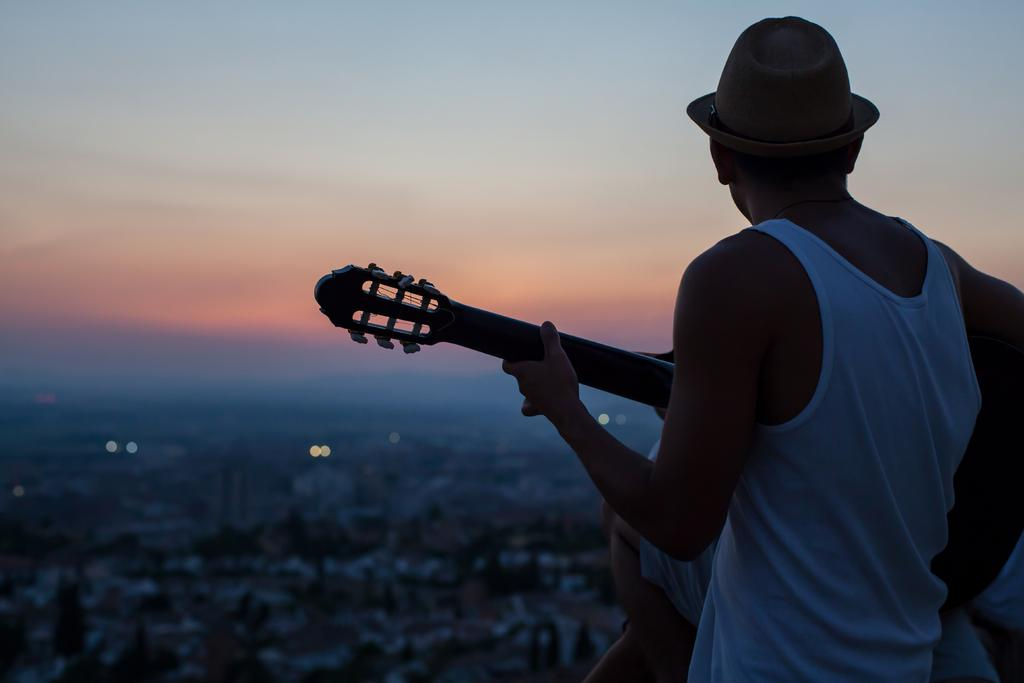How many people are in the image? There are people in the image, but the exact number is not specified. What are the people in the image doing? A person is playing a musical instrument in the image. Can you describe the appearance of the person playing the musical instrument? The person playing the musical instrument is wearing a hat. What can be seen in the background of the image? The sky is visible in the image, and the background is blurred. What type of umbrella is the carpenter using to form the musical instrument in the image? There is no carpenter, umbrella, or form involved in the creation of the musical instrument in the image. The person playing the musical instrument is already wearing a hat, and there is no indication of any carpentry or umbrella usage. 